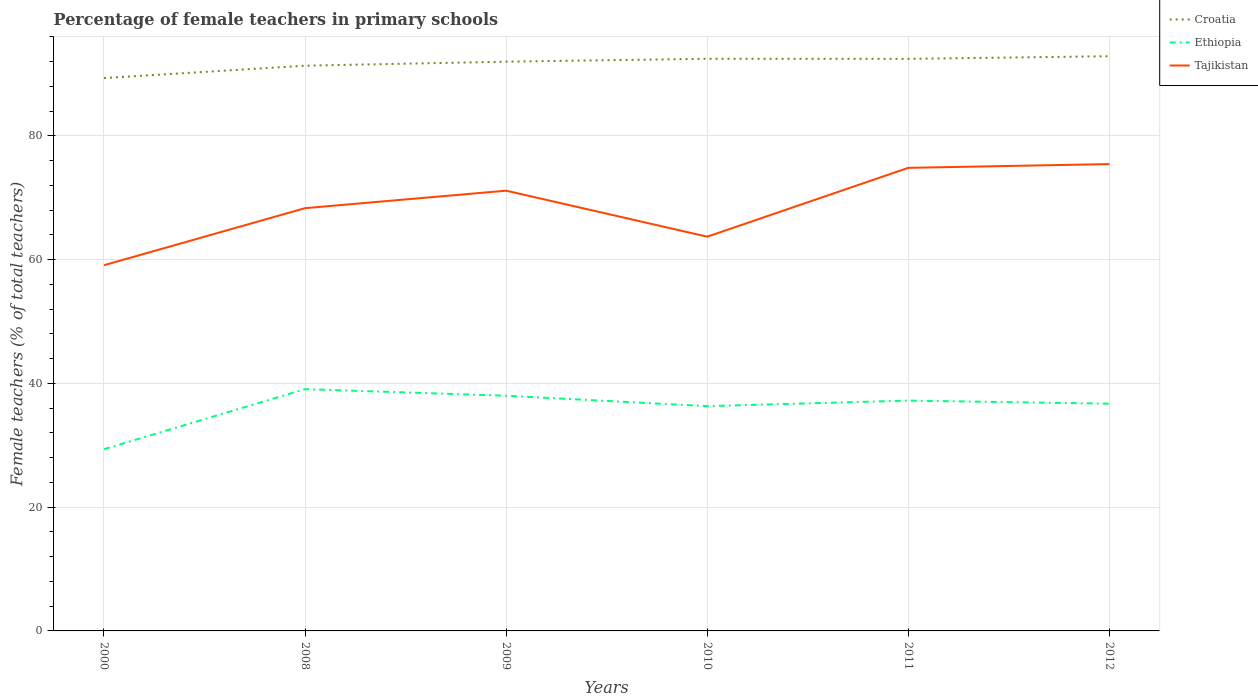Does the line corresponding to Tajikistan intersect with the line corresponding to Ethiopia?
Make the answer very short. No. Across all years, what is the maximum percentage of female teachers in Tajikistan?
Provide a succinct answer. 59.1. In which year was the percentage of female teachers in Ethiopia maximum?
Offer a very short reply. 2000. What is the total percentage of female teachers in Ethiopia in the graph?
Make the answer very short. 1.85. What is the difference between the highest and the second highest percentage of female teachers in Croatia?
Make the answer very short. 3.53. What is the difference between the highest and the lowest percentage of female teachers in Tajikistan?
Offer a terse response. 3. Is the percentage of female teachers in Croatia strictly greater than the percentage of female teachers in Tajikistan over the years?
Your response must be concise. No. Does the graph contain any zero values?
Your response must be concise. No. Does the graph contain grids?
Provide a succinct answer. Yes. Where does the legend appear in the graph?
Give a very brief answer. Top right. How many legend labels are there?
Keep it short and to the point. 3. What is the title of the graph?
Keep it short and to the point. Percentage of female teachers in primary schools. Does "Liberia" appear as one of the legend labels in the graph?
Keep it short and to the point. No. What is the label or title of the X-axis?
Make the answer very short. Years. What is the label or title of the Y-axis?
Give a very brief answer. Female teachers (% of total teachers). What is the Female teachers (% of total teachers) in Croatia in 2000?
Your answer should be very brief. 89.34. What is the Female teachers (% of total teachers) of Ethiopia in 2000?
Ensure brevity in your answer.  29.37. What is the Female teachers (% of total teachers) of Tajikistan in 2000?
Your response must be concise. 59.1. What is the Female teachers (% of total teachers) in Croatia in 2008?
Make the answer very short. 91.35. What is the Female teachers (% of total teachers) of Ethiopia in 2008?
Provide a short and direct response. 39.08. What is the Female teachers (% of total teachers) in Tajikistan in 2008?
Provide a short and direct response. 68.32. What is the Female teachers (% of total teachers) of Croatia in 2009?
Your answer should be compact. 92. What is the Female teachers (% of total teachers) of Ethiopia in 2009?
Make the answer very short. 38.01. What is the Female teachers (% of total teachers) in Tajikistan in 2009?
Your response must be concise. 71.15. What is the Female teachers (% of total teachers) of Croatia in 2010?
Offer a terse response. 92.47. What is the Female teachers (% of total teachers) in Ethiopia in 2010?
Provide a short and direct response. 36.33. What is the Female teachers (% of total teachers) of Tajikistan in 2010?
Provide a succinct answer. 63.71. What is the Female teachers (% of total teachers) of Croatia in 2011?
Give a very brief answer. 92.45. What is the Female teachers (% of total teachers) in Ethiopia in 2011?
Your response must be concise. 37.22. What is the Female teachers (% of total teachers) in Tajikistan in 2011?
Your answer should be compact. 74.84. What is the Female teachers (% of total teachers) in Croatia in 2012?
Provide a succinct answer. 92.88. What is the Female teachers (% of total teachers) of Ethiopia in 2012?
Give a very brief answer. 36.73. What is the Female teachers (% of total teachers) of Tajikistan in 2012?
Make the answer very short. 75.44. Across all years, what is the maximum Female teachers (% of total teachers) in Croatia?
Your answer should be very brief. 92.88. Across all years, what is the maximum Female teachers (% of total teachers) in Ethiopia?
Provide a succinct answer. 39.08. Across all years, what is the maximum Female teachers (% of total teachers) of Tajikistan?
Provide a succinct answer. 75.44. Across all years, what is the minimum Female teachers (% of total teachers) in Croatia?
Make the answer very short. 89.34. Across all years, what is the minimum Female teachers (% of total teachers) in Ethiopia?
Provide a short and direct response. 29.37. Across all years, what is the minimum Female teachers (% of total teachers) of Tajikistan?
Give a very brief answer. 59.1. What is the total Female teachers (% of total teachers) in Croatia in the graph?
Provide a succinct answer. 550.48. What is the total Female teachers (% of total teachers) in Ethiopia in the graph?
Your answer should be compact. 216.73. What is the total Female teachers (% of total teachers) of Tajikistan in the graph?
Offer a very short reply. 412.57. What is the difference between the Female teachers (% of total teachers) in Croatia in 2000 and that in 2008?
Make the answer very short. -2. What is the difference between the Female teachers (% of total teachers) in Ethiopia in 2000 and that in 2008?
Offer a terse response. -9.71. What is the difference between the Female teachers (% of total teachers) of Tajikistan in 2000 and that in 2008?
Give a very brief answer. -9.22. What is the difference between the Female teachers (% of total teachers) in Croatia in 2000 and that in 2009?
Provide a succinct answer. -2.65. What is the difference between the Female teachers (% of total teachers) in Ethiopia in 2000 and that in 2009?
Give a very brief answer. -8.64. What is the difference between the Female teachers (% of total teachers) of Tajikistan in 2000 and that in 2009?
Give a very brief answer. -12.05. What is the difference between the Female teachers (% of total teachers) in Croatia in 2000 and that in 2010?
Offer a terse response. -3.12. What is the difference between the Female teachers (% of total teachers) of Ethiopia in 2000 and that in 2010?
Your answer should be very brief. -6.96. What is the difference between the Female teachers (% of total teachers) of Tajikistan in 2000 and that in 2010?
Offer a very short reply. -4.61. What is the difference between the Female teachers (% of total teachers) of Croatia in 2000 and that in 2011?
Provide a short and direct response. -3.11. What is the difference between the Female teachers (% of total teachers) in Ethiopia in 2000 and that in 2011?
Your response must be concise. -7.85. What is the difference between the Female teachers (% of total teachers) of Tajikistan in 2000 and that in 2011?
Provide a short and direct response. -15.74. What is the difference between the Female teachers (% of total teachers) in Croatia in 2000 and that in 2012?
Your answer should be compact. -3.53. What is the difference between the Female teachers (% of total teachers) of Ethiopia in 2000 and that in 2012?
Ensure brevity in your answer.  -7.36. What is the difference between the Female teachers (% of total teachers) of Tajikistan in 2000 and that in 2012?
Offer a terse response. -16.34. What is the difference between the Female teachers (% of total teachers) of Croatia in 2008 and that in 2009?
Offer a terse response. -0.65. What is the difference between the Female teachers (% of total teachers) of Ethiopia in 2008 and that in 2009?
Provide a succinct answer. 1.07. What is the difference between the Female teachers (% of total teachers) in Tajikistan in 2008 and that in 2009?
Offer a terse response. -2.83. What is the difference between the Female teachers (% of total teachers) in Croatia in 2008 and that in 2010?
Provide a short and direct response. -1.12. What is the difference between the Female teachers (% of total teachers) of Ethiopia in 2008 and that in 2010?
Your answer should be compact. 2.75. What is the difference between the Female teachers (% of total teachers) of Tajikistan in 2008 and that in 2010?
Provide a succinct answer. 4.61. What is the difference between the Female teachers (% of total teachers) of Croatia in 2008 and that in 2011?
Your answer should be compact. -1.1. What is the difference between the Female teachers (% of total teachers) in Ethiopia in 2008 and that in 2011?
Your answer should be very brief. 1.85. What is the difference between the Female teachers (% of total teachers) in Tajikistan in 2008 and that in 2011?
Make the answer very short. -6.52. What is the difference between the Female teachers (% of total teachers) in Croatia in 2008 and that in 2012?
Your answer should be compact. -1.53. What is the difference between the Female teachers (% of total teachers) in Ethiopia in 2008 and that in 2012?
Ensure brevity in your answer.  2.35. What is the difference between the Female teachers (% of total teachers) in Tajikistan in 2008 and that in 2012?
Make the answer very short. -7.12. What is the difference between the Female teachers (% of total teachers) of Croatia in 2009 and that in 2010?
Your response must be concise. -0.47. What is the difference between the Female teachers (% of total teachers) in Ethiopia in 2009 and that in 2010?
Your answer should be very brief. 1.68. What is the difference between the Female teachers (% of total teachers) in Tajikistan in 2009 and that in 2010?
Your answer should be very brief. 7.43. What is the difference between the Female teachers (% of total teachers) in Croatia in 2009 and that in 2011?
Provide a succinct answer. -0.46. What is the difference between the Female teachers (% of total teachers) in Ethiopia in 2009 and that in 2011?
Your answer should be compact. 0.79. What is the difference between the Female teachers (% of total teachers) in Tajikistan in 2009 and that in 2011?
Provide a succinct answer. -3.69. What is the difference between the Female teachers (% of total teachers) of Croatia in 2009 and that in 2012?
Make the answer very short. -0.88. What is the difference between the Female teachers (% of total teachers) in Ethiopia in 2009 and that in 2012?
Your answer should be very brief. 1.28. What is the difference between the Female teachers (% of total teachers) in Tajikistan in 2009 and that in 2012?
Your answer should be very brief. -4.3. What is the difference between the Female teachers (% of total teachers) in Croatia in 2010 and that in 2011?
Offer a terse response. 0.01. What is the difference between the Female teachers (% of total teachers) in Ethiopia in 2010 and that in 2011?
Make the answer very short. -0.9. What is the difference between the Female teachers (% of total teachers) of Tajikistan in 2010 and that in 2011?
Offer a very short reply. -11.13. What is the difference between the Female teachers (% of total teachers) of Croatia in 2010 and that in 2012?
Your answer should be compact. -0.41. What is the difference between the Female teachers (% of total teachers) of Ethiopia in 2010 and that in 2012?
Provide a succinct answer. -0.4. What is the difference between the Female teachers (% of total teachers) in Tajikistan in 2010 and that in 2012?
Give a very brief answer. -11.73. What is the difference between the Female teachers (% of total teachers) in Croatia in 2011 and that in 2012?
Keep it short and to the point. -0.43. What is the difference between the Female teachers (% of total teachers) of Ethiopia in 2011 and that in 2012?
Keep it short and to the point. 0.5. What is the difference between the Female teachers (% of total teachers) of Tajikistan in 2011 and that in 2012?
Offer a terse response. -0.6. What is the difference between the Female teachers (% of total teachers) in Croatia in 2000 and the Female teachers (% of total teachers) in Ethiopia in 2008?
Provide a succinct answer. 50.27. What is the difference between the Female teachers (% of total teachers) in Croatia in 2000 and the Female teachers (% of total teachers) in Tajikistan in 2008?
Your answer should be compact. 21.02. What is the difference between the Female teachers (% of total teachers) of Ethiopia in 2000 and the Female teachers (% of total teachers) of Tajikistan in 2008?
Your answer should be compact. -38.95. What is the difference between the Female teachers (% of total teachers) in Croatia in 2000 and the Female teachers (% of total teachers) in Ethiopia in 2009?
Offer a terse response. 51.33. What is the difference between the Female teachers (% of total teachers) in Croatia in 2000 and the Female teachers (% of total teachers) in Tajikistan in 2009?
Keep it short and to the point. 18.2. What is the difference between the Female teachers (% of total teachers) of Ethiopia in 2000 and the Female teachers (% of total teachers) of Tajikistan in 2009?
Keep it short and to the point. -41.78. What is the difference between the Female teachers (% of total teachers) of Croatia in 2000 and the Female teachers (% of total teachers) of Ethiopia in 2010?
Offer a very short reply. 53.02. What is the difference between the Female teachers (% of total teachers) of Croatia in 2000 and the Female teachers (% of total teachers) of Tajikistan in 2010?
Give a very brief answer. 25.63. What is the difference between the Female teachers (% of total teachers) of Ethiopia in 2000 and the Female teachers (% of total teachers) of Tajikistan in 2010?
Provide a succinct answer. -34.34. What is the difference between the Female teachers (% of total teachers) of Croatia in 2000 and the Female teachers (% of total teachers) of Ethiopia in 2011?
Make the answer very short. 52.12. What is the difference between the Female teachers (% of total teachers) in Croatia in 2000 and the Female teachers (% of total teachers) in Tajikistan in 2011?
Ensure brevity in your answer.  14.5. What is the difference between the Female teachers (% of total teachers) in Ethiopia in 2000 and the Female teachers (% of total teachers) in Tajikistan in 2011?
Offer a very short reply. -45.47. What is the difference between the Female teachers (% of total teachers) of Croatia in 2000 and the Female teachers (% of total teachers) of Ethiopia in 2012?
Offer a very short reply. 52.62. What is the difference between the Female teachers (% of total teachers) in Croatia in 2000 and the Female teachers (% of total teachers) in Tajikistan in 2012?
Your response must be concise. 13.9. What is the difference between the Female teachers (% of total teachers) in Ethiopia in 2000 and the Female teachers (% of total teachers) in Tajikistan in 2012?
Your answer should be compact. -46.07. What is the difference between the Female teachers (% of total teachers) of Croatia in 2008 and the Female teachers (% of total teachers) of Ethiopia in 2009?
Your response must be concise. 53.34. What is the difference between the Female teachers (% of total teachers) of Croatia in 2008 and the Female teachers (% of total teachers) of Tajikistan in 2009?
Give a very brief answer. 20.2. What is the difference between the Female teachers (% of total teachers) in Ethiopia in 2008 and the Female teachers (% of total teachers) in Tajikistan in 2009?
Make the answer very short. -32.07. What is the difference between the Female teachers (% of total teachers) in Croatia in 2008 and the Female teachers (% of total teachers) in Ethiopia in 2010?
Keep it short and to the point. 55.02. What is the difference between the Female teachers (% of total teachers) in Croatia in 2008 and the Female teachers (% of total teachers) in Tajikistan in 2010?
Ensure brevity in your answer.  27.63. What is the difference between the Female teachers (% of total teachers) of Ethiopia in 2008 and the Female teachers (% of total teachers) of Tajikistan in 2010?
Offer a terse response. -24.64. What is the difference between the Female teachers (% of total teachers) of Croatia in 2008 and the Female teachers (% of total teachers) of Ethiopia in 2011?
Make the answer very short. 54.12. What is the difference between the Female teachers (% of total teachers) in Croatia in 2008 and the Female teachers (% of total teachers) in Tajikistan in 2011?
Provide a short and direct response. 16.51. What is the difference between the Female teachers (% of total teachers) in Ethiopia in 2008 and the Female teachers (% of total teachers) in Tajikistan in 2011?
Your answer should be compact. -35.77. What is the difference between the Female teachers (% of total teachers) of Croatia in 2008 and the Female teachers (% of total teachers) of Ethiopia in 2012?
Keep it short and to the point. 54.62. What is the difference between the Female teachers (% of total teachers) of Croatia in 2008 and the Female teachers (% of total teachers) of Tajikistan in 2012?
Give a very brief answer. 15.9. What is the difference between the Female teachers (% of total teachers) of Ethiopia in 2008 and the Female teachers (% of total teachers) of Tajikistan in 2012?
Your response must be concise. -36.37. What is the difference between the Female teachers (% of total teachers) in Croatia in 2009 and the Female teachers (% of total teachers) in Ethiopia in 2010?
Your response must be concise. 55.67. What is the difference between the Female teachers (% of total teachers) in Croatia in 2009 and the Female teachers (% of total teachers) in Tajikistan in 2010?
Ensure brevity in your answer.  28.28. What is the difference between the Female teachers (% of total teachers) in Ethiopia in 2009 and the Female teachers (% of total teachers) in Tajikistan in 2010?
Provide a succinct answer. -25.7. What is the difference between the Female teachers (% of total teachers) in Croatia in 2009 and the Female teachers (% of total teachers) in Ethiopia in 2011?
Provide a succinct answer. 54.77. What is the difference between the Female teachers (% of total teachers) of Croatia in 2009 and the Female teachers (% of total teachers) of Tajikistan in 2011?
Your answer should be compact. 17.15. What is the difference between the Female teachers (% of total teachers) of Ethiopia in 2009 and the Female teachers (% of total teachers) of Tajikistan in 2011?
Make the answer very short. -36.83. What is the difference between the Female teachers (% of total teachers) of Croatia in 2009 and the Female teachers (% of total teachers) of Ethiopia in 2012?
Make the answer very short. 55.27. What is the difference between the Female teachers (% of total teachers) of Croatia in 2009 and the Female teachers (% of total teachers) of Tajikistan in 2012?
Your answer should be very brief. 16.55. What is the difference between the Female teachers (% of total teachers) in Ethiopia in 2009 and the Female teachers (% of total teachers) in Tajikistan in 2012?
Offer a very short reply. -37.43. What is the difference between the Female teachers (% of total teachers) of Croatia in 2010 and the Female teachers (% of total teachers) of Ethiopia in 2011?
Give a very brief answer. 55.24. What is the difference between the Female teachers (% of total teachers) in Croatia in 2010 and the Female teachers (% of total teachers) in Tajikistan in 2011?
Offer a very short reply. 17.62. What is the difference between the Female teachers (% of total teachers) in Ethiopia in 2010 and the Female teachers (% of total teachers) in Tajikistan in 2011?
Your response must be concise. -38.51. What is the difference between the Female teachers (% of total teachers) of Croatia in 2010 and the Female teachers (% of total teachers) of Ethiopia in 2012?
Your answer should be compact. 55.74. What is the difference between the Female teachers (% of total teachers) of Croatia in 2010 and the Female teachers (% of total teachers) of Tajikistan in 2012?
Ensure brevity in your answer.  17.02. What is the difference between the Female teachers (% of total teachers) in Ethiopia in 2010 and the Female teachers (% of total teachers) in Tajikistan in 2012?
Your answer should be compact. -39.12. What is the difference between the Female teachers (% of total teachers) in Croatia in 2011 and the Female teachers (% of total teachers) in Ethiopia in 2012?
Provide a succinct answer. 55.73. What is the difference between the Female teachers (% of total teachers) in Croatia in 2011 and the Female teachers (% of total teachers) in Tajikistan in 2012?
Offer a terse response. 17.01. What is the difference between the Female teachers (% of total teachers) of Ethiopia in 2011 and the Female teachers (% of total teachers) of Tajikistan in 2012?
Make the answer very short. -38.22. What is the average Female teachers (% of total teachers) of Croatia per year?
Provide a short and direct response. 91.75. What is the average Female teachers (% of total teachers) of Ethiopia per year?
Offer a terse response. 36.12. What is the average Female teachers (% of total teachers) of Tajikistan per year?
Provide a short and direct response. 68.76. In the year 2000, what is the difference between the Female teachers (% of total teachers) in Croatia and Female teachers (% of total teachers) in Ethiopia?
Make the answer very short. 59.98. In the year 2000, what is the difference between the Female teachers (% of total teachers) in Croatia and Female teachers (% of total teachers) in Tajikistan?
Keep it short and to the point. 30.25. In the year 2000, what is the difference between the Female teachers (% of total teachers) in Ethiopia and Female teachers (% of total teachers) in Tajikistan?
Make the answer very short. -29.73. In the year 2008, what is the difference between the Female teachers (% of total teachers) of Croatia and Female teachers (% of total teachers) of Ethiopia?
Your response must be concise. 52.27. In the year 2008, what is the difference between the Female teachers (% of total teachers) of Croatia and Female teachers (% of total teachers) of Tajikistan?
Provide a succinct answer. 23.02. In the year 2008, what is the difference between the Female teachers (% of total teachers) of Ethiopia and Female teachers (% of total teachers) of Tajikistan?
Your answer should be compact. -29.25. In the year 2009, what is the difference between the Female teachers (% of total teachers) of Croatia and Female teachers (% of total teachers) of Ethiopia?
Make the answer very short. 53.99. In the year 2009, what is the difference between the Female teachers (% of total teachers) in Croatia and Female teachers (% of total teachers) in Tajikistan?
Your answer should be very brief. 20.85. In the year 2009, what is the difference between the Female teachers (% of total teachers) of Ethiopia and Female teachers (% of total teachers) of Tajikistan?
Offer a terse response. -33.14. In the year 2010, what is the difference between the Female teachers (% of total teachers) in Croatia and Female teachers (% of total teachers) in Ethiopia?
Provide a short and direct response. 56.14. In the year 2010, what is the difference between the Female teachers (% of total teachers) of Croatia and Female teachers (% of total teachers) of Tajikistan?
Make the answer very short. 28.75. In the year 2010, what is the difference between the Female teachers (% of total teachers) of Ethiopia and Female teachers (% of total teachers) of Tajikistan?
Provide a short and direct response. -27.39. In the year 2011, what is the difference between the Female teachers (% of total teachers) in Croatia and Female teachers (% of total teachers) in Ethiopia?
Provide a short and direct response. 55.23. In the year 2011, what is the difference between the Female teachers (% of total teachers) in Croatia and Female teachers (% of total teachers) in Tajikistan?
Provide a short and direct response. 17.61. In the year 2011, what is the difference between the Female teachers (% of total teachers) of Ethiopia and Female teachers (% of total teachers) of Tajikistan?
Offer a very short reply. -37.62. In the year 2012, what is the difference between the Female teachers (% of total teachers) in Croatia and Female teachers (% of total teachers) in Ethiopia?
Provide a short and direct response. 56.15. In the year 2012, what is the difference between the Female teachers (% of total teachers) in Croatia and Female teachers (% of total teachers) in Tajikistan?
Ensure brevity in your answer.  17.43. In the year 2012, what is the difference between the Female teachers (% of total teachers) of Ethiopia and Female teachers (% of total teachers) of Tajikistan?
Offer a very short reply. -38.72. What is the ratio of the Female teachers (% of total teachers) in Croatia in 2000 to that in 2008?
Give a very brief answer. 0.98. What is the ratio of the Female teachers (% of total teachers) of Ethiopia in 2000 to that in 2008?
Offer a very short reply. 0.75. What is the ratio of the Female teachers (% of total teachers) in Tajikistan in 2000 to that in 2008?
Ensure brevity in your answer.  0.86. What is the ratio of the Female teachers (% of total teachers) in Croatia in 2000 to that in 2009?
Provide a succinct answer. 0.97. What is the ratio of the Female teachers (% of total teachers) in Ethiopia in 2000 to that in 2009?
Your answer should be compact. 0.77. What is the ratio of the Female teachers (% of total teachers) of Tajikistan in 2000 to that in 2009?
Provide a succinct answer. 0.83. What is the ratio of the Female teachers (% of total teachers) of Croatia in 2000 to that in 2010?
Ensure brevity in your answer.  0.97. What is the ratio of the Female teachers (% of total teachers) of Ethiopia in 2000 to that in 2010?
Provide a succinct answer. 0.81. What is the ratio of the Female teachers (% of total teachers) in Tajikistan in 2000 to that in 2010?
Ensure brevity in your answer.  0.93. What is the ratio of the Female teachers (% of total teachers) of Croatia in 2000 to that in 2011?
Keep it short and to the point. 0.97. What is the ratio of the Female teachers (% of total teachers) of Ethiopia in 2000 to that in 2011?
Ensure brevity in your answer.  0.79. What is the ratio of the Female teachers (% of total teachers) in Tajikistan in 2000 to that in 2011?
Provide a short and direct response. 0.79. What is the ratio of the Female teachers (% of total teachers) in Croatia in 2000 to that in 2012?
Provide a short and direct response. 0.96. What is the ratio of the Female teachers (% of total teachers) of Ethiopia in 2000 to that in 2012?
Make the answer very short. 0.8. What is the ratio of the Female teachers (% of total teachers) of Tajikistan in 2000 to that in 2012?
Your answer should be very brief. 0.78. What is the ratio of the Female teachers (% of total teachers) of Croatia in 2008 to that in 2009?
Your answer should be compact. 0.99. What is the ratio of the Female teachers (% of total teachers) in Ethiopia in 2008 to that in 2009?
Offer a very short reply. 1.03. What is the ratio of the Female teachers (% of total teachers) of Tajikistan in 2008 to that in 2009?
Provide a short and direct response. 0.96. What is the ratio of the Female teachers (% of total teachers) of Croatia in 2008 to that in 2010?
Provide a short and direct response. 0.99. What is the ratio of the Female teachers (% of total teachers) of Ethiopia in 2008 to that in 2010?
Make the answer very short. 1.08. What is the ratio of the Female teachers (% of total teachers) in Tajikistan in 2008 to that in 2010?
Your answer should be compact. 1.07. What is the ratio of the Female teachers (% of total teachers) of Ethiopia in 2008 to that in 2011?
Provide a succinct answer. 1.05. What is the ratio of the Female teachers (% of total teachers) in Tajikistan in 2008 to that in 2011?
Ensure brevity in your answer.  0.91. What is the ratio of the Female teachers (% of total teachers) of Croatia in 2008 to that in 2012?
Ensure brevity in your answer.  0.98. What is the ratio of the Female teachers (% of total teachers) of Ethiopia in 2008 to that in 2012?
Your answer should be compact. 1.06. What is the ratio of the Female teachers (% of total teachers) of Tajikistan in 2008 to that in 2012?
Keep it short and to the point. 0.91. What is the ratio of the Female teachers (% of total teachers) of Croatia in 2009 to that in 2010?
Provide a short and direct response. 0.99. What is the ratio of the Female teachers (% of total teachers) of Ethiopia in 2009 to that in 2010?
Offer a terse response. 1.05. What is the ratio of the Female teachers (% of total teachers) in Tajikistan in 2009 to that in 2010?
Offer a terse response. 1.12. What is the ratio of the Female teachers (% of total teachers) in Ethiopia in 2009 to that in 2011?
Offer a very short reply. 1.02. What is the ratio of the Female teachers (% of total teachers) in Tajikistan in 2009 to that in 2011?
Your answer should be compact. 0.95. What is the ratio of the Female teachers (% of total teachers) of Ethiopia in 2009 to that in 2012?
Provide a short and direct response. 1.03. What is the ratio of the Female teachers (% of total teachers) of Tajikistan in 2009 to that in 2012?
Provide a succinct answer. 0.94. What is the ratio of the Female teachers (% of total teachers) in Croatia in 2010 to that in 2011?
Your response must be concise. 1. What is the ratio of the Female teachers (% of total teachers) of Ethiopia in 2010 to that in 2011?
Give a very brief answer. 0.98. What is the ratio of the Female teachers (% of total teachers) in Tajikistan in 2010 to that in 2011?
Keep it short and to the point. 0.85. What is the ratio of the Female teachers (% of total teachers) of Croatia in 2010 to that in 2012?
Offer a terse response. 1. What is the ratio of the Female teachers (% of total teachers) in Ethiopia in 2010 to that in 2012?
Make the answer very short. 0.99. What is the ratio of the Female teachers (% of total teachers) in Tajikistan in 2010 to that in 2012?
Keep it short and to the point. 0.84. What is the ratio of the Female teachers (% of total teachers) of Ethiopia in 2011 to that in 2012?
Your answer should be compact. 1.01. What is the difference between the highest and the second highest Female teachers (% of total teachers) of Croatia?
Your response must be concise. 0.41. What is the difference between the highest and the second highest Female teachers (% of total teachers) of Ethiopia?
Keep it short and to the point. 1.07. What is the difference between the highest and the second highest Female teachers (% of total teachers) in Tajikistan?
Ensure brevity in your answer.  0.6. What is the difference between the highest and the lowest Female teachers (% of total teachers) in Croatia?
Provide a short and direct response. 3.53. What is the difference between the highest and the lowest Female teachers (% of total teachers) of Ethiopia?
Provide a succinct answer. 9.71. What is the difference between the highest and the lowest Female teachers (% of total teachers) in Tajikistan?
Provide a short and direct response. 16.34. 